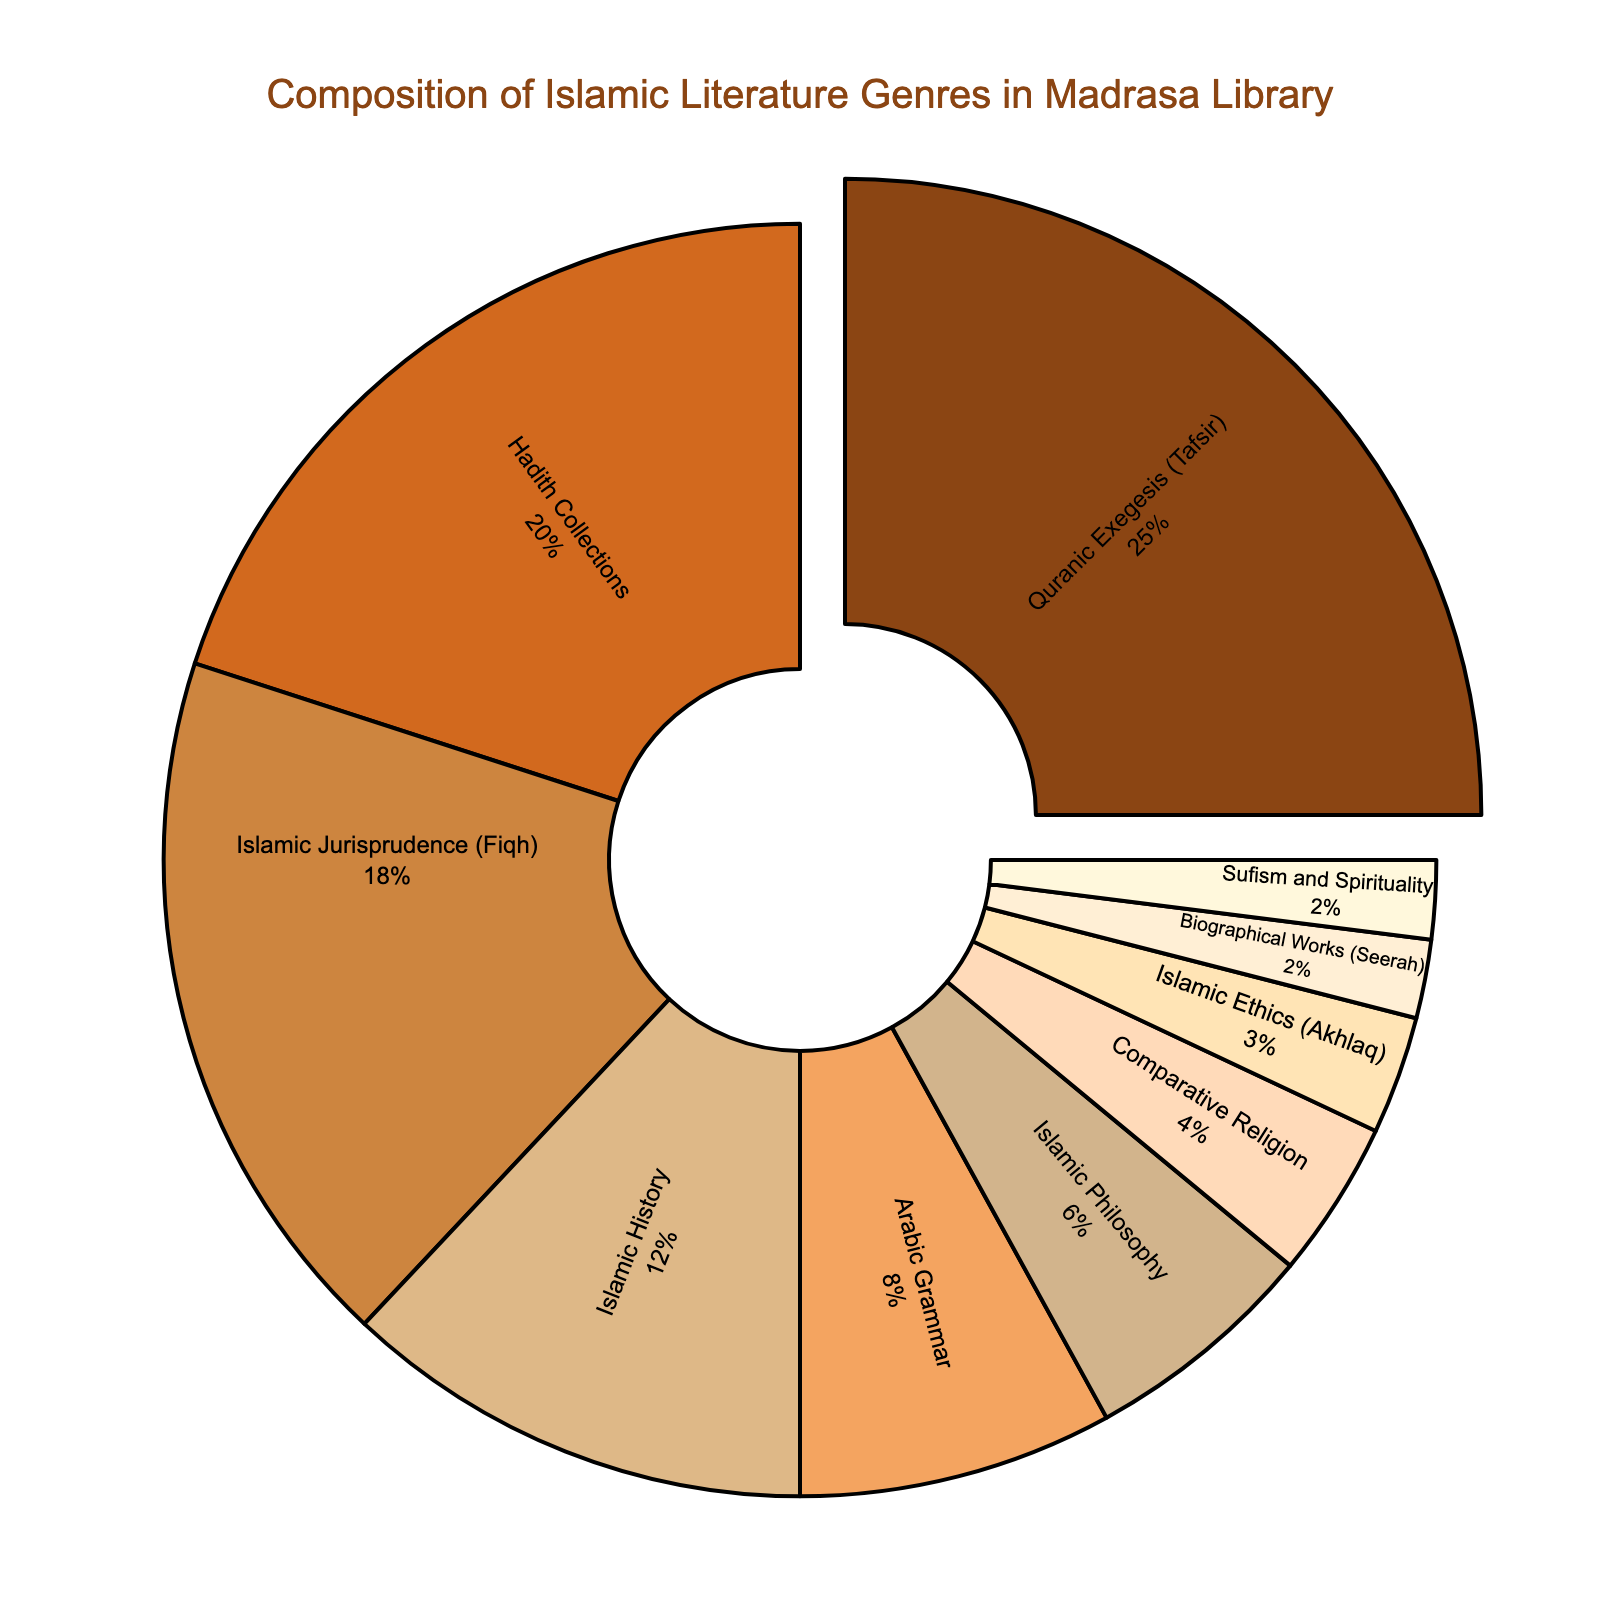What genre constitutes the largest percentage in the Madrasa library composition? The largest segment in the pie chart represents the highest percentage of literature. By looking at the visual, the largest section is Quranic Exegesis (Tafsir) which is emphasized by being pulled out slightly from the pie.
Answer: Quranic Exegesis (Tafsir) Which genre takes up a quarter of the Madrasa library's collection? A quarter is equivalent to 25%. Looking closely at the pie, Quranic Exegesis (Tafsir) accounts for 25% of the total composition.
Answer: Quranic Exegesis (Tafsir) What is the combined percentage of Biographical Works (Seerah) and Sufism and Spirituality genres in the Madrasa library? Biographical Works (Seerah) and Sufism and Spirituality each account for 2%. Adding these two, 2% + 2% makes 4%.
Answer: 4% Which genre has a larger percentage, Arabic Grammar or Islamic Philosophy? By comparing the two sections of the pie chart, Arabic Grammar is larger with 8% compared to Islamic Philosophy’s 6%.
Answer: Arabic Grammar What's the combined percentage of Hadith Collections, Islamic Jurisprudence (Fiqh), and Islamic History? Summing up the percentages: Hadith Collections (20%), Islamic Jurisprudence (Fiqh) (18%), and Islamic History (12%) gives 20% + 18% + 12% = 50%.
Answer: 50% Which color on the chart corresponds to Comparative Religion? The color representing Comparative Religion can be identified in the chart. It’s depicted in a soft peach tone among the segments.
Answer: soft peach tone Compared to Islamic Philosophy, how much more percentage does Islamic Jurisprudence (Fiqh) have? Islamic Jurisprudence (Fiqh) has 18%, while Islamic Philosophy has 6%. The difference is calculated as 18% - 6% = 12%.
Answer: 12% more Which two genres combined make up the smallest percentage of the library's collection? The smallest percentages are Biographical Works (Seerah) and Sufism and Spirituality, each at 2%. Together, they make up 2% + 2% = 4%. No other combination is smaller than this.
Answer: Biographical Works (Seerah) and Sufism and Spirituality Which genre is represented by the color that is most similar to gold? The closest to gold in the color palette of the pie chart is the section representing Islamic Ethics (Akhlaq), indicated by a very light golden-brown shade.
Answer: Islamic Ethics (Akhlaq) 